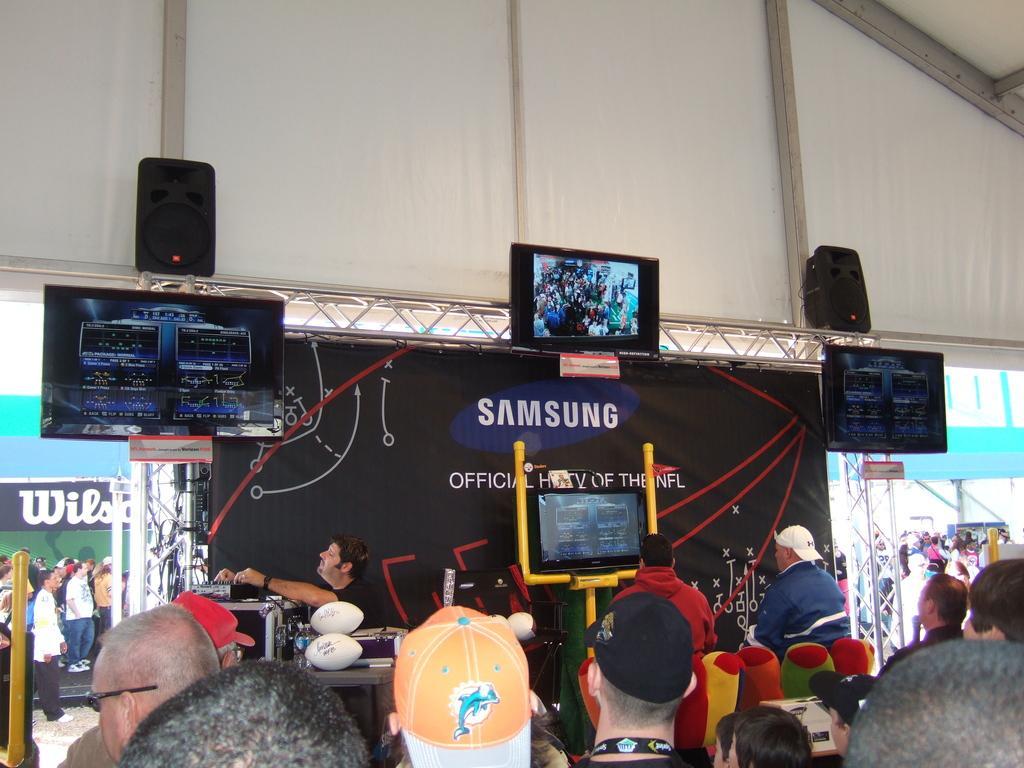Could you give a brief overview of what you see in this image? In the foreground of the image we can see a group of people are standing. In the middle of the image we can see monitors, a poster and two persons are sitting and watching the screen. On the top of the image we can see the speakers and roof. 